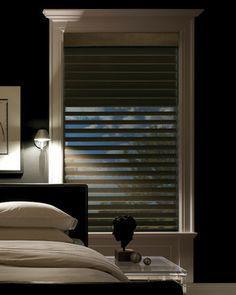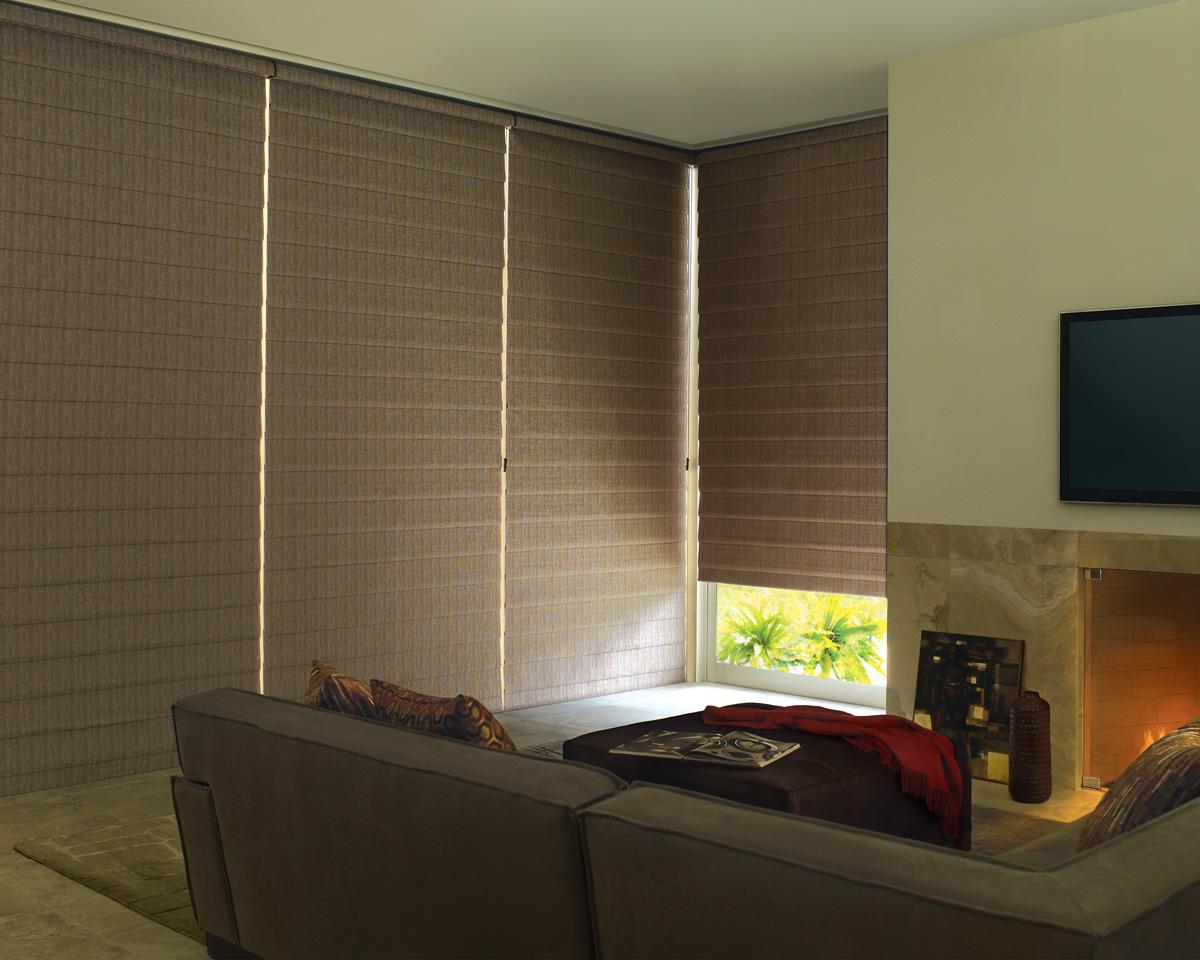The first image is the image on the left, the second image is the image on the right. Given the left and right images, does the statement "In at least one image there is a pant on a side table in front of blinds." hold true? Answer yes or no. Yes. 